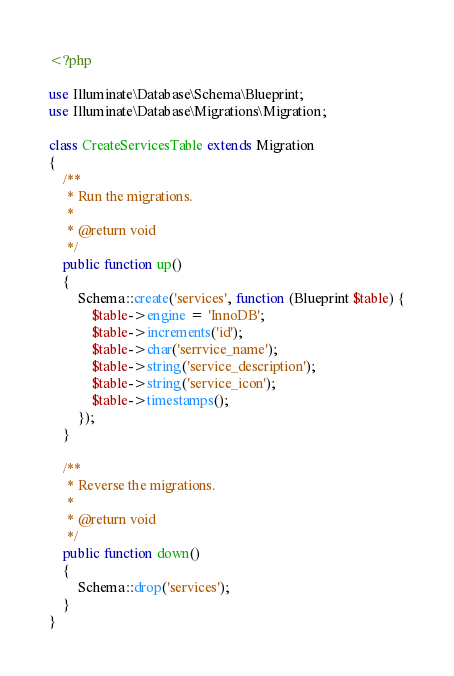Convert code to text. <code><loc_0><loc_0><loc_500><loc_500><_PHP_><?php

use Illuminate\Database\Schema\Blueprint;
use Illuminate\Database\Migrations\Migration;

class CreateServicesTable extends Migration
{
    /**
     * Run the migrations.
     *
     * @return void
     */
    public function up()
    {
        Schema::create('services', function (Blueprint $table) {
            $table->engine = 'InnoDB';
            $table->increments('id');
            $table->char('serrvice_name');
            $table->string('service_description');
            $table->string('service_icon');
            $table->timestamps();
        });
    }

    /**
     * Reverse the migrations.
     *
     * @return void
     */
    public function down()
    {
        Schema::drop('services');
    }
}
</code> 